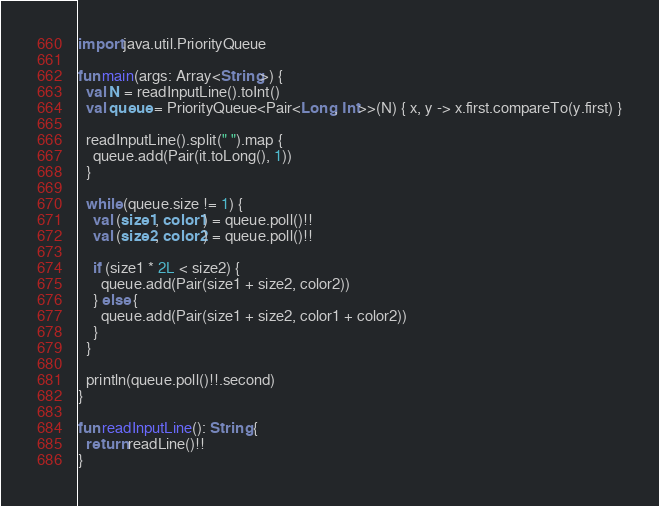<code> <loc_0><loc_0><loc_500><loc_500><_Kotlin_>import java.util.PriorityQueue

fun main(args: Array<String>) {
  val N = readInputLine().toInt()
  val queue = PriorityQueue<Pair<Long, Int>>(N) { x, y -> x.first.compareTo(y.first) }
  
  readInputLine().split(" ").map {
    queue.add(Pair(it.toLong(), 1))
  }
  
  while (queue.size != 1) {
    val (size1, color1) = queue.poll()!!
    val (size2, color2) = queue.poll()!!
    
    if (size1 * 2L < size2) {
      queue.add(Pair(size1 + size2, color2))
    } else {
      queue.add(Pair(size1 + size2, color1 + color2))
    }
  }
  
  println(queue.poll()!!.second)
}

fun readInputLine(): String {
  return readLine()!!
}
</code> 